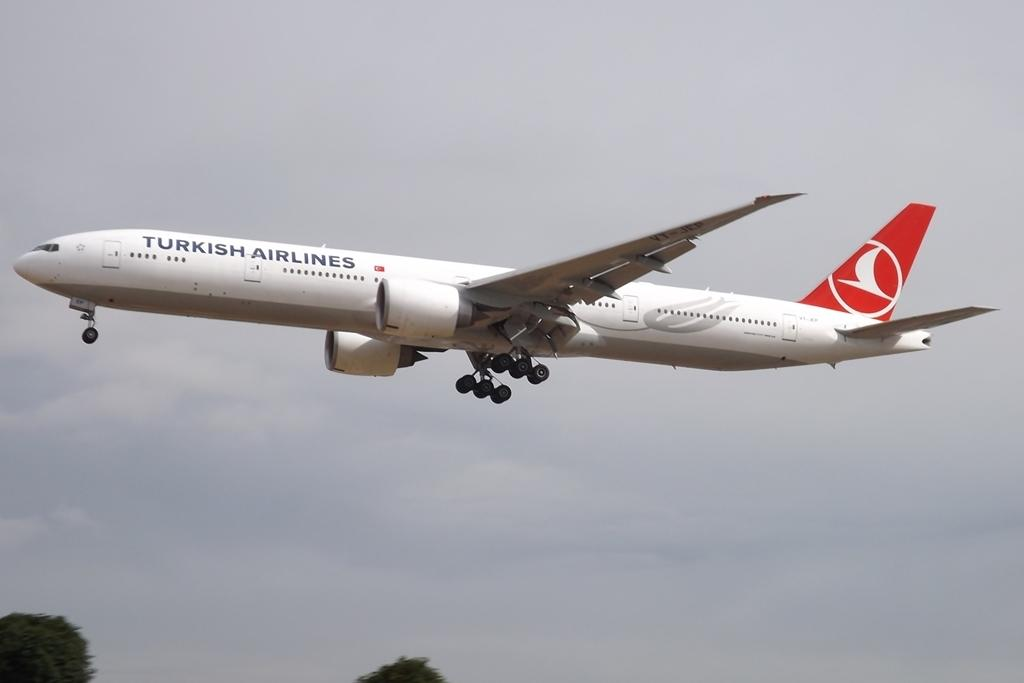<image>
Relay a brief, clear account of the picture shown. a plane that is from Turkish airlines and is white 